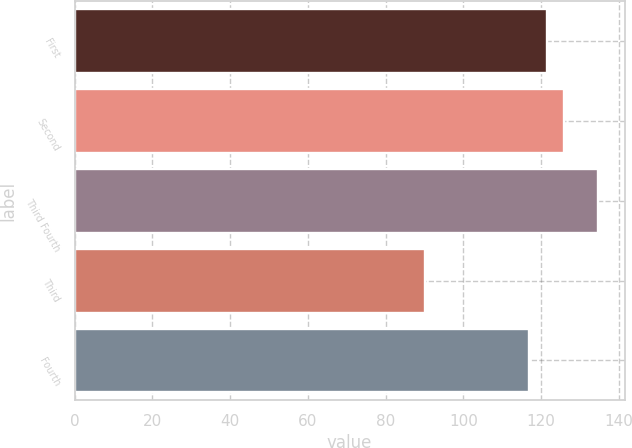<chart> <loc_0><loc_0><loc_500><loc_500><bar_chart><fcel>First<fcel>Second<fcel>Third Fourth<fcel>Third<fcel>Fourth<nl><fcel>121.43<fcel>125.9<fcel>134.77<fcel>90.09<fcel>116.96<nl></chart> 